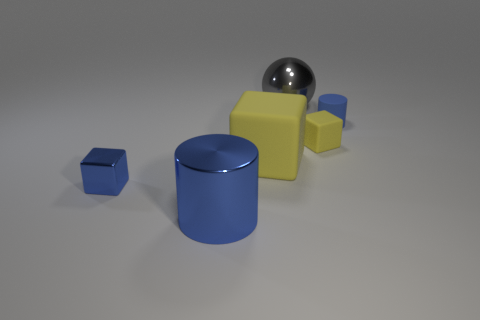Is the material of the tiny cylinder the same as the big gray ball?
Provide a short and direct response. No. Is the number of things behind the small blue shiny block greater than the number of big gray things?
Provide a succinct answer. Yes. What is the material of the yellow block that is right of the object behind the tiny blue thing behind the small yellow matte object?
Provide a succinct answer. Rubber. What number of things are either yellow blocks or large objects in front of the large sphere?
Your answer should be very brief. 3. There is a thing that is on the left side of the large blue cylinder; does it have the same color as the metallic cylinder?
Your answer should be compact. Yes. Is the number of yellow rubber cubes behind the large cube greater than the number of large shiny spheres that are behind the large gray metallic thing?
Give a very brief answer. Yes. Is there anything else of the same color as the sphere?
Your response must be concise. No. What number of objects are either matte blocks or metallic spheres?
Offer a very short reply. 3. Is the size of the yellow matte block that is to the left of the ball the same as the gray sphere?
Your response must be concise. Yes. How many other objects are there of the same size as the gray sphere?
Keep it short and to the point. 2. 